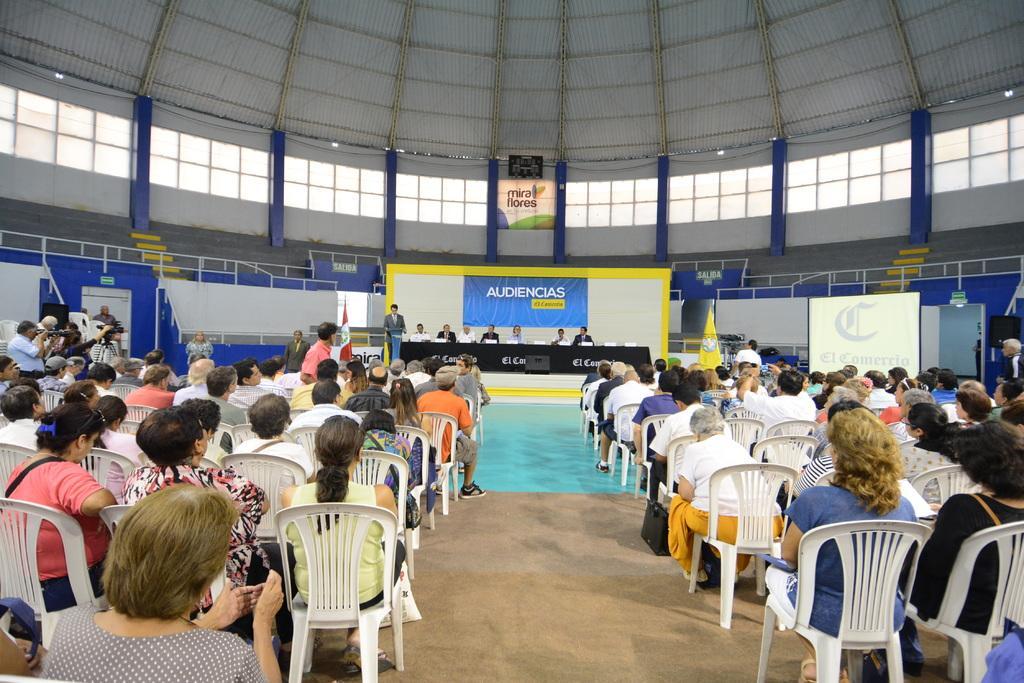Please provide a concise description of this image. In this picture there are group of people those who are sitting on chairs in front of the stage and there is a stage at the center of the image and there are some people those who are sitting on the stage, it seems to be an auditorium. 